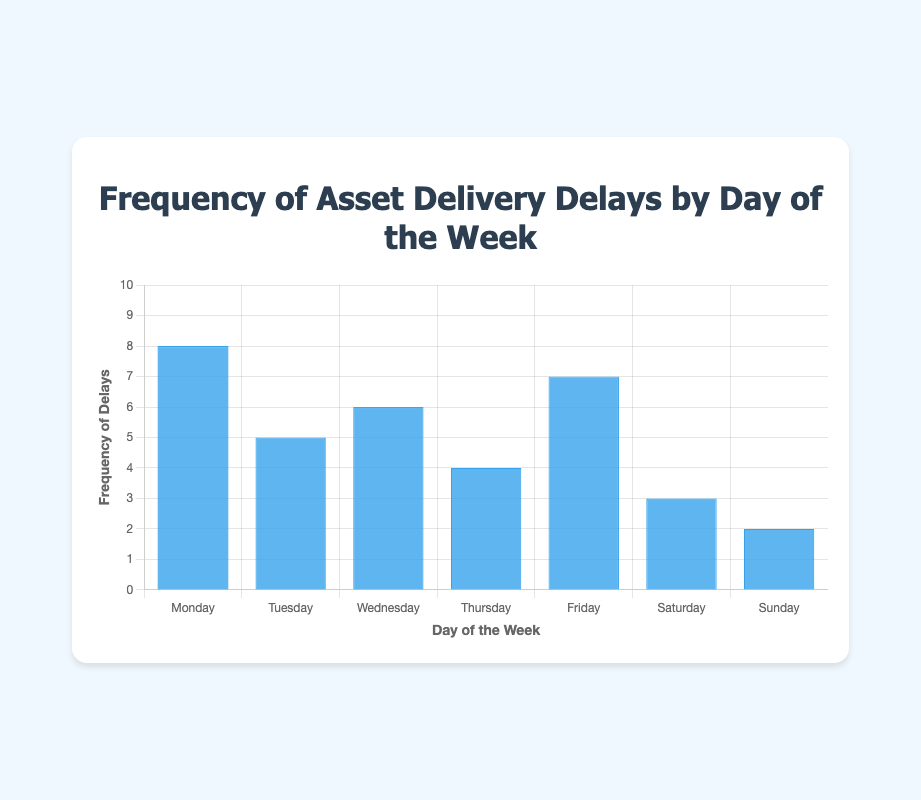Which day has the highest frequency of asset delivery delays? The highest bar in the chart represents Monday, with a frequency of 8.
Answer: Monday Which day has the lowest frequency of asset delivery delays? The shortest bar in the chart represents Sunday, with a frequency of 2.
Answer: Sunday How many more delays occur on Friday compared to Thursday? Find the frequency on Friday and Thursday and subtract Thursday's from Friday's (7 - 4).
Answer: 3 What is the average frequency of asset delivery delays for the weekdays (Monday to Friday)? Sum the values for Monday to Friday: 8 + 5 + 6 + 4 + 7 = 30. Then divide by the number of days (5).
Answer: 6 Which day has more asset delivery delays: Tuesday or Wednesday? Compare the heights of the bars for Tuesday (5) and Wednesday (6). Wednesday has a higher frequency.
Answer: Wednesday What is the total frequency of asset delivery delays for the weekends (Saturday and Sunday)? Sum the values for Saturday and Sunday: 3 + 2 = 5.
Answer: 5 Is the frequency of delivery delays on Thursday equal to or higher than the frequency on Saturday? Compare the heights of the bars for Thursday (4) and Saturday (3). Thursday is higher.
Answer: Higher What is the difference in frequency between the day with the most delays and the day with the least delays? Subtract the lowest frequency (2 on Sunday) from the highest frequency (8 on Monday): 8 - 2.
Answer: 6 What is the combined frequency of delays for days that have more than 6 delays? Identify days with more than 6 delays (Monday: 8 and Friday: 7). Sum the frequencies: 8 + 7 = 15.
Answer: 15 How many days have a frequency of asset delivery delays less than 5? Identify the days with frequencies less than 5 (Thursday: 4, Saturday: 3, and Sunday: 2). Count the days.
Answer: 3 